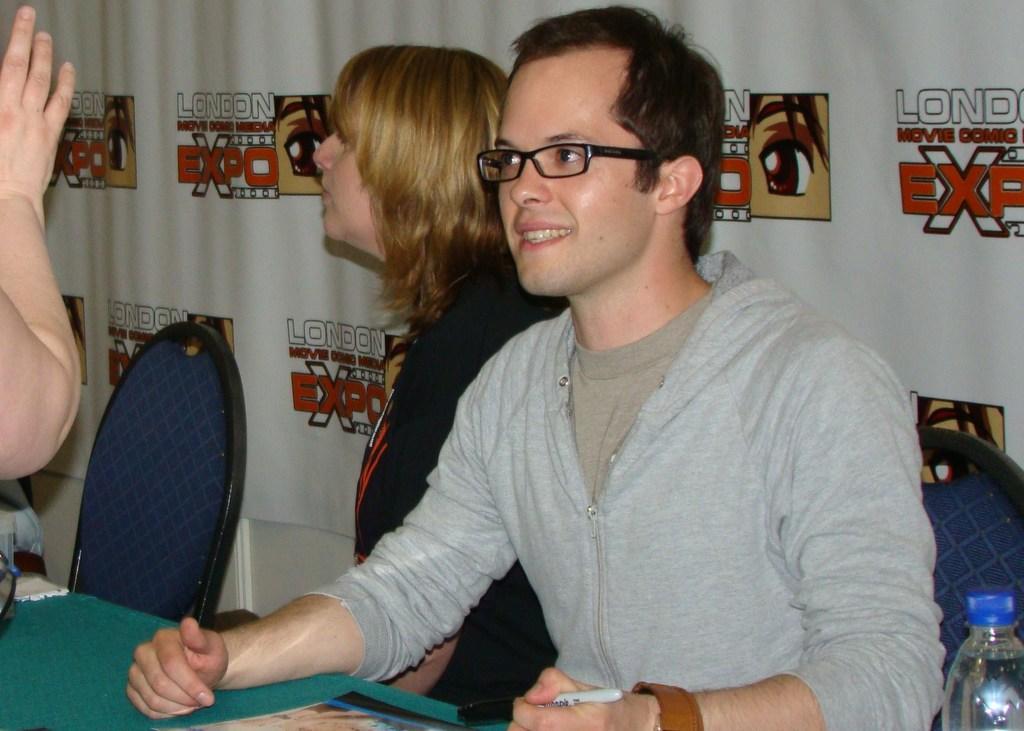Describe this image in one or two sentences. In this image i can see a man is sitting on a chair beside a woman in front of a table. 